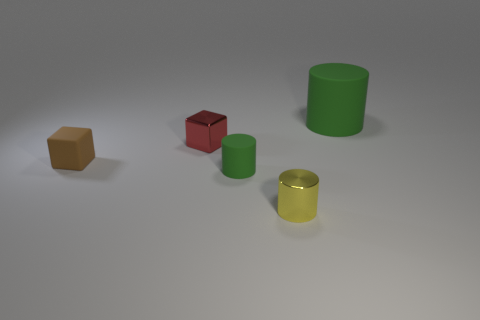Do the green object that is on the left side of the large rubber cylinder and the small block in front of the red object have the same material?
Your response must be concise. Yes. There is a cylinder that is both behind the small yellow cylinder and to the right of the small matte cylinder; what size is it?
Offer a terse response. Large. What material is the yellow cylinder that is the same size as the brown thing?
Make the answer very short. Metal. What number of tiny red metal things are on the right side of the green matte object behind the small metal object that is to the left of the yellow shiny cylinder?
Give a very brief answer. 0. There is a matte cylinder in front of the large green rubber cylinder; is its color the same as the matte cylinder that is behind the tiny brown rubber block?
Ensure brevity in your answer.  Yes. What color is the rubber object that is to the right of the red metal cube and to the left of the big green matte thing?
Provide a short and direct response. Green. What number of brown things have the same size as the red metal cube?
Ensure brevity in your answer.  1. What is the shape of the green thing in front of the matte object behind the small red metallic thing?
Ensure brevity in your answer.  Cylinder. What shape is the object in front of the green rubber cylinder that is left of the cylinder that is behind the matte block?
Your answer should be compact. Cylinder. What number of brown objects are the same shape as the tiny green rubber object?
Ensure brevity in your answer.  0. 